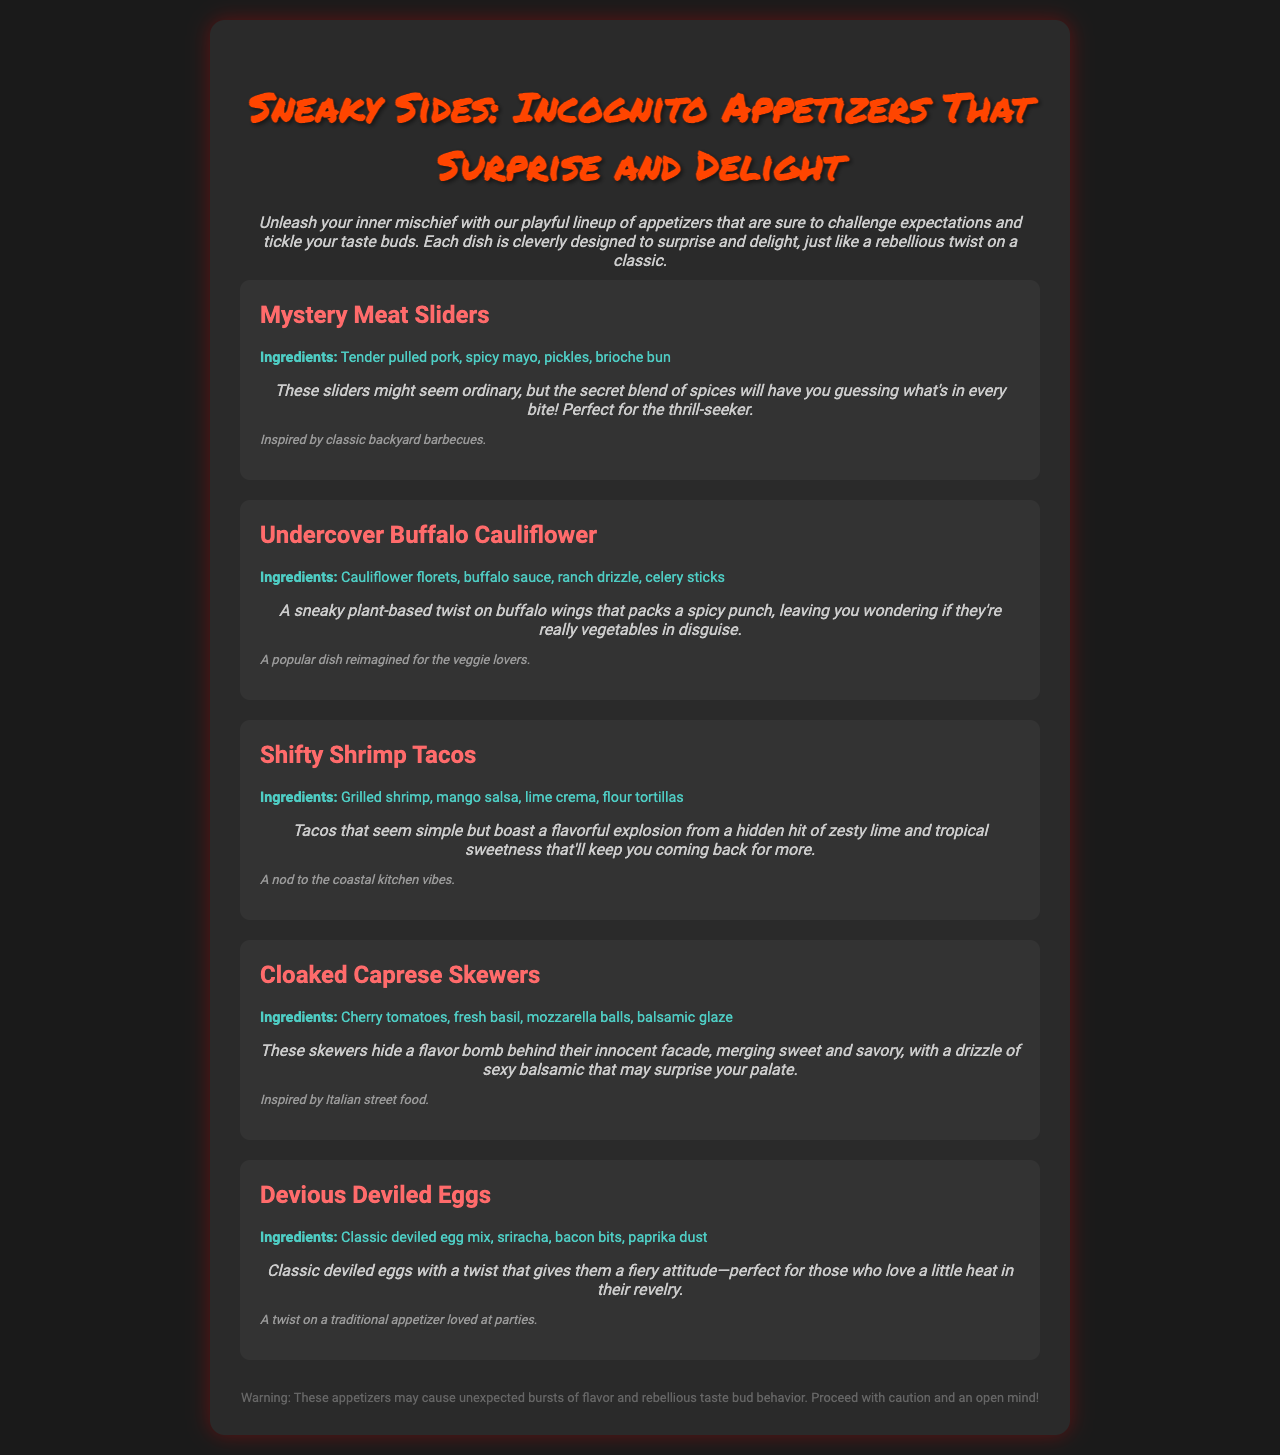What is the title of the menu? The title of the menu is prominently displayed at the top, stating "Sneaky Sides: Incognito Appetizers That Surprise and Delight."
Answer: Sneaky Sides: Incognito Appetizers That Surprise and Delight How many appetizers are listed on the menu? The document contains five distinct appetizers named in the menu.
Answer: Five What ingredient is used in the Mystery Meat Sliders? The ingredients for the Mystery Meat Sliders include pulled pork, spicy mayo, pickles, and a brioche bun.
Answer: Pulled pork What is the unique twist in the Undercover Buffalo Cauliflower? The Undercover Buffalo Cauliflower is described as a plant-based twist that surprises with its flavor, hinting at an unexpected quality in a typical dish.
Answer: Plant-based twist Which appetizer is inspired by Italian street food? The Cloaked Caprese Skewers are indicated to draw inspiration from Italian street food within the description.
Answer: Cloaked Caprese Skewers What kind of sauce is included in the Shifty Shrimp Tacos? The Shifty Shrimp Tacos contain mango salsa and lime crema, both contributing to their flavor profile.
Answer: Mango salsa, lime crema Which appetizer contains sriracha? The Devious Deviled Eggs are specifically noted to include sriracha, giving them a spicy character.
Answer: Devious Deviled Eggs What color is the background of the menu? The background color is said to be a dark shade, which is consistently referred to throughout the document.
Answer: Dark shade (black) 